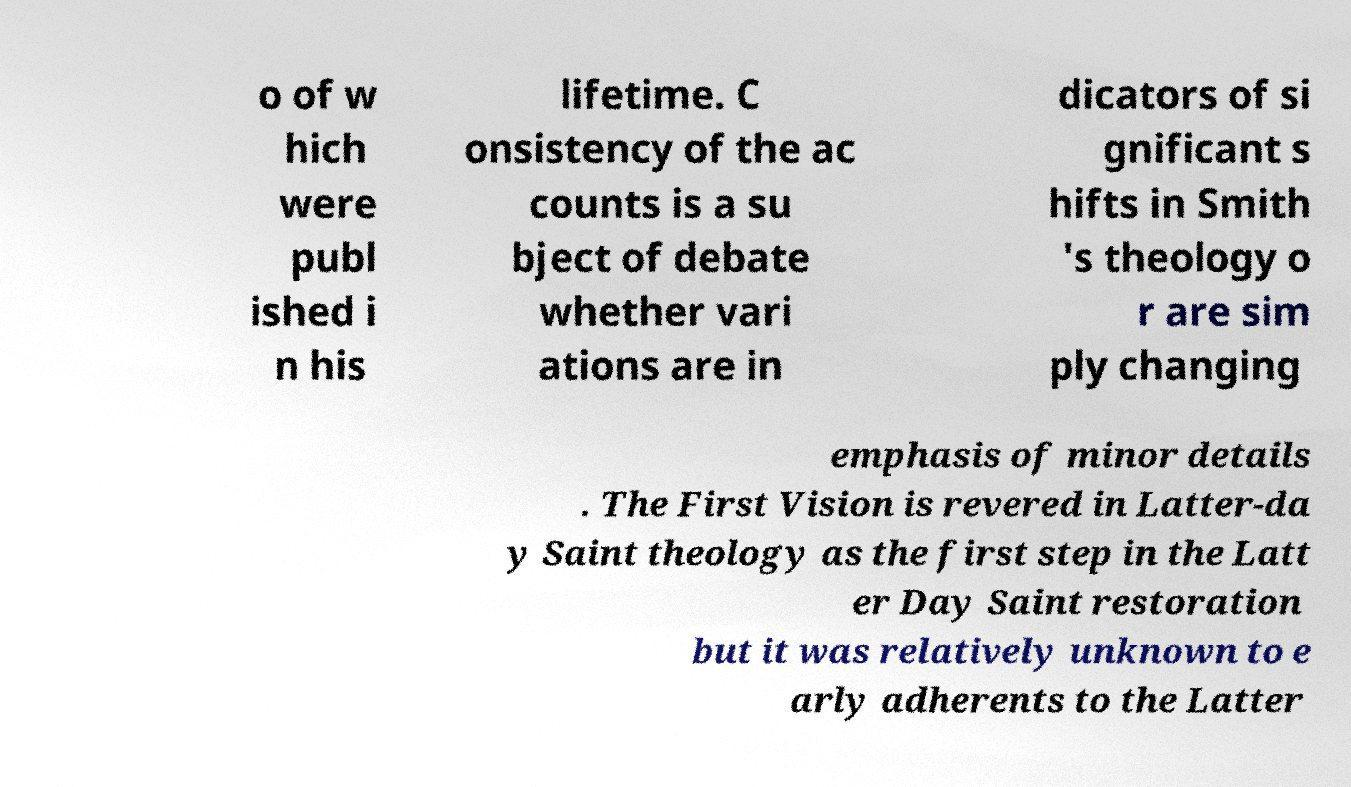Can you read and provide the text displayed in the image?This photo seems to have some interesting text. Can you extract and type it out for me? o of w hich were publ ished i n his lifetime. C onsistency of the ac counts is a su bject of debate whether vari ations are in dicators of si gnificant s hifts in Smith 's theology o r are sim ply changing emphasis of minor details . The First Vision is revered in Latter-da y Saint theology as the first step in the Latt er Day Saint restoration but it was relatively unknown to e arly adherents to the Latter 